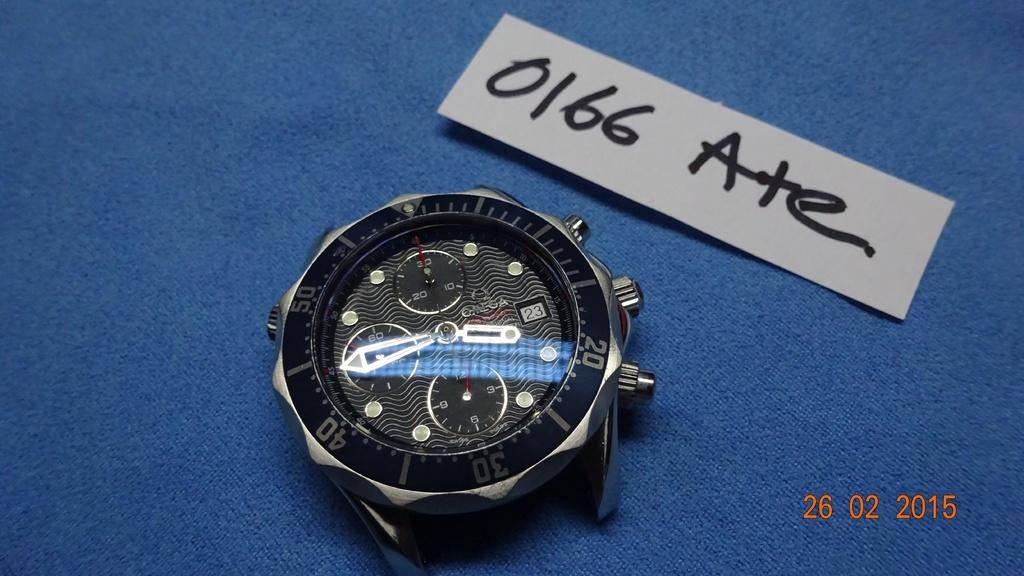<image>
Write a terse but informative summary of the picture. A photograph taken on February 26, 2015 shows a watch face. 